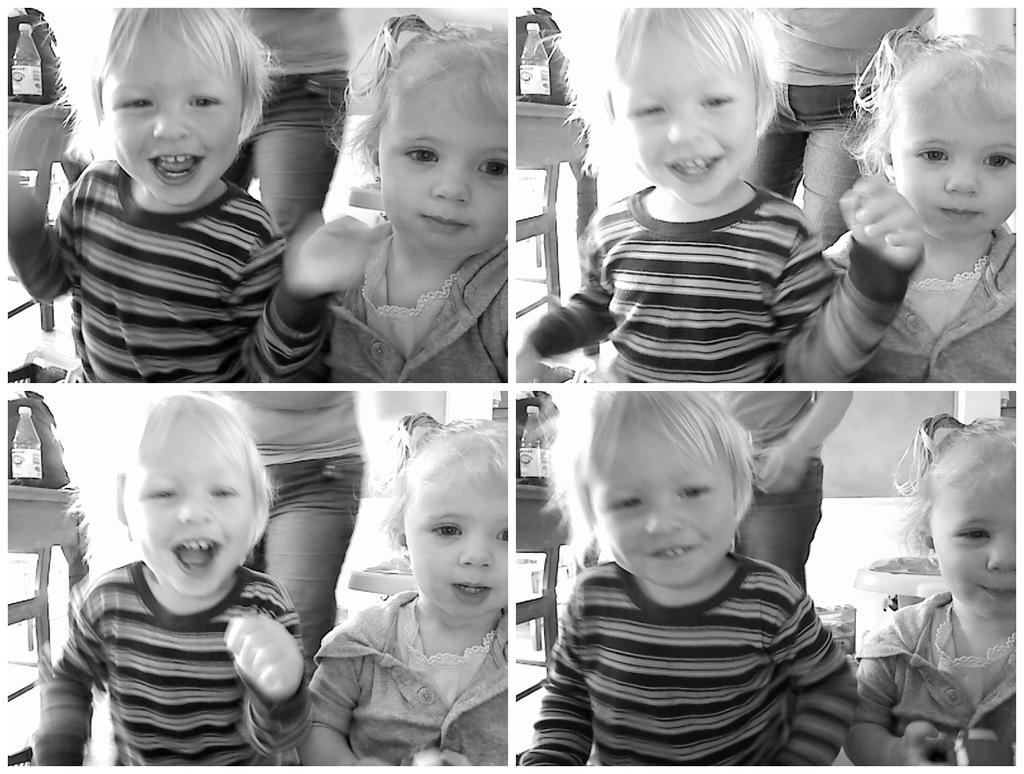What type of artwork is the image? The image is a collage. Who can be seen in the image? There are children and a person in the image. What piece of furniture is present in the image? There is a table in the image. What items are placed on the table? A bag and a bottle are placed on the table. What type of joke is being told by the children in the image? There is no indication in the image that the children are telling a joke, so it cannot be determined from the picture. 